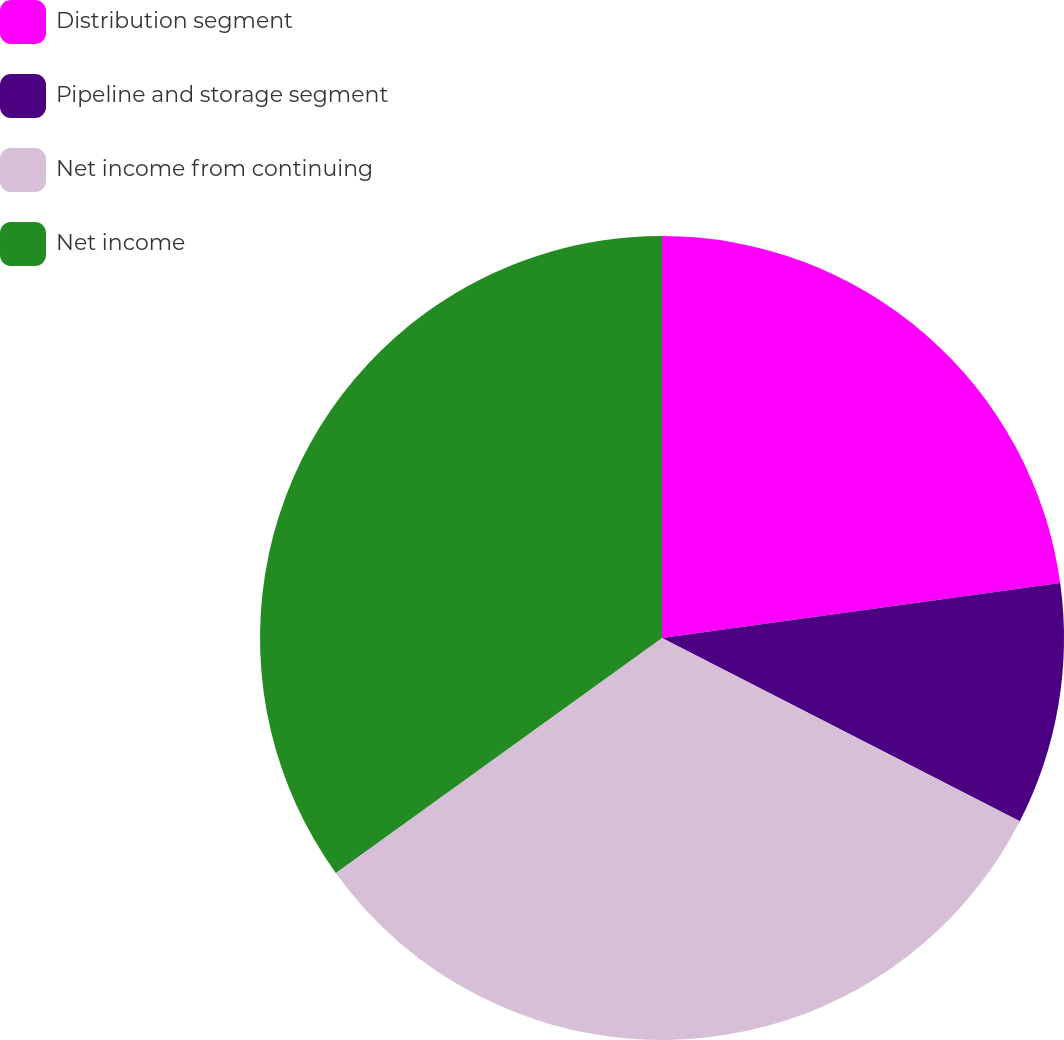Convert chart. <chart><loc_0><loc_0><loc_500><loc_500><pie_chart><fcel>Distribution segment<fcel>Pipeline and storage segment<fcel>Net income from continuing<fcel>Net income<nl><fcel>22.81%<fcel>9.72%<fcel>32.53%<fcel>34.93%<nl></chart> 